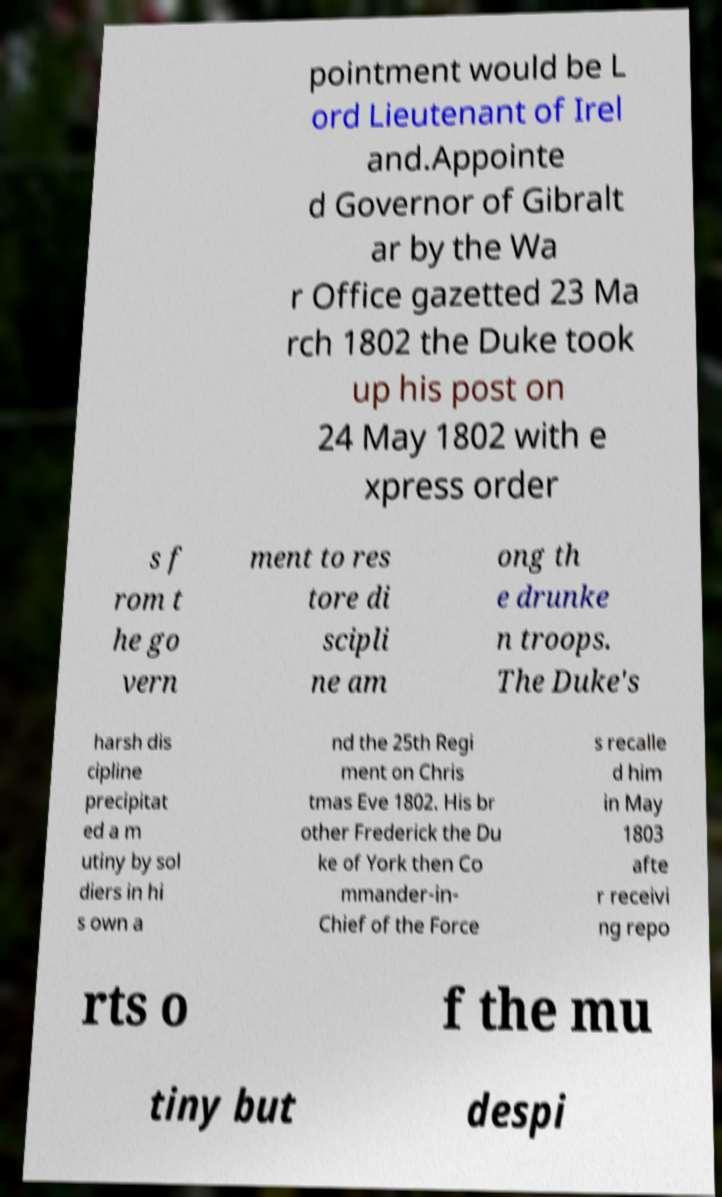For documentation purposes, I need the text within this image transcribed. Could you provide that? pointment would be L ord Lieutenant of Irel and.Appointe d Governor of Gibralt ar by the Wa r Office gazetted 23 Ma rch 1802 the Duke took up his post on 24 May 1802 with e xpress order s f rom t he go vern ment to res tore di scipli ne am ong th e drunke n troops. The Duke's harsh dis cipline precipitat ed a m utiny by sol diers in hi s own a nd the 25th Regi ment on Chris tmas Eve 1802. His br other Frederick the Du ke of York then Co mmander-in- Chief of the Force s recalle d him in May 1803 afte r receivi ng repo rts o f the mu tiny but despi 